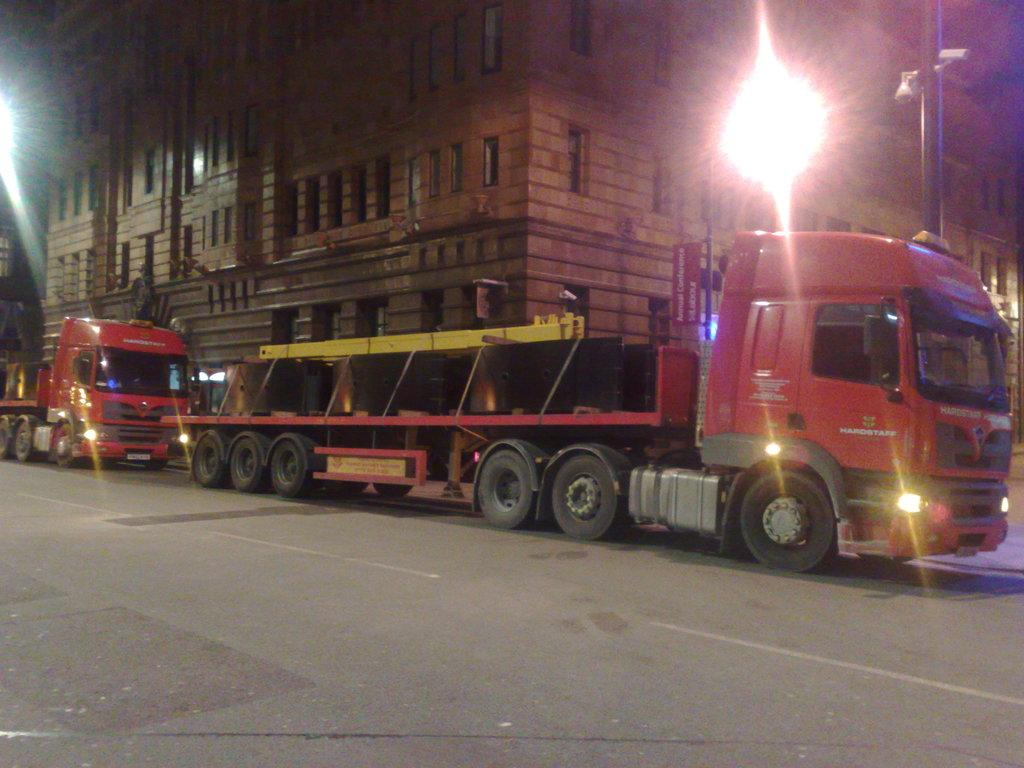What type of vehicles can be seen on the road in the image? There are trucks on the road in the image. What can be seen in the distance behind the trucks? There is a building and lights visible in the background of the image. What structure is present in the background of the image? There is a pole in the background of the image. What type of bread is being taxed in the image? There is no bread or tax-related information present in the image. 